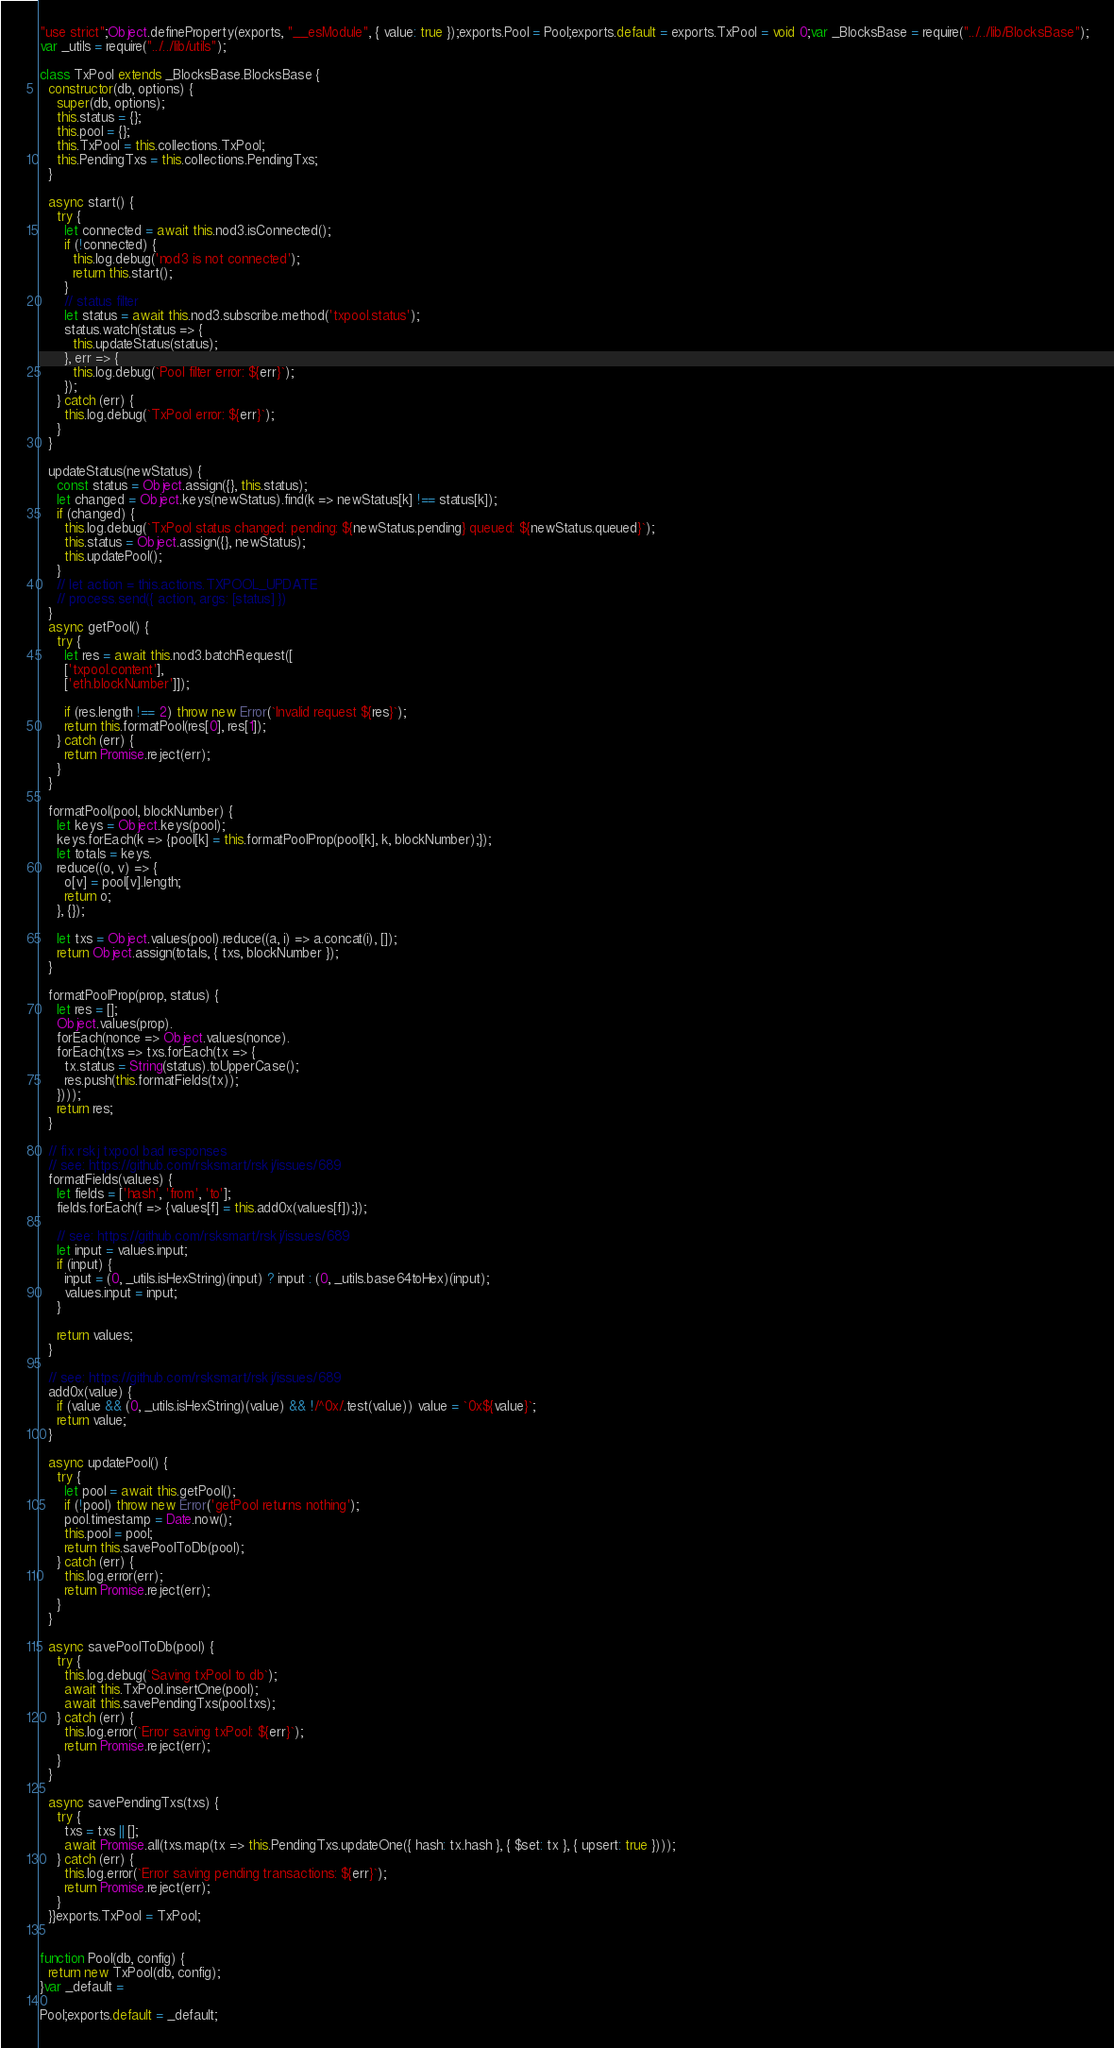Convert code to text. <code><loc_0><loc_0><loc_500><loc_500><_JavaScript_>"use strict";Object.defineProperty(exports, "__esModule", { value: true });exports.Pool = Pool;exports.default = exports.TxPool = void 0;var _BlocksBase = require("../../lib/BlocksBase");
var _utils = require("../../lib/utils");

class TxPool extends _BlocksBase.BlocksBase {
  constructor(db, options) {
    super(db, options);
    this.status = {};
    this.pool = {};
    this.TxPool = this.collections.TxPool;
    this.PendingTxs = this.collections.PendingTxs;
  }

  async start() {
    try {
      let connected = await this.nod3.isConnected();
      if (!connected) {
        this.log.debug('nod3 is not connected');
        return this.start();
      }
      // status filter
      let status = await this.nod3.subscribe.method('txpool.status');
      status.watch(status => {
        this.updateStatus(status);
      }, err => {
        this.log.debug(`Pool filter error: ${err}`);
      });
    } catch (err) {
      this.log.debug(`TxPool error: ${err}`);
    }
  }

  updateStatus(newStatus) {
    const status = Object.assign({}, this.status);
    let changed = Object.keys(newStatus).find(k => newStatus[k] !== status[k]);
    if (changed) {
      this.log.debug(`TxPool status changed: pending: ${newStatus.pending} queued: ${newStatus.queued}`);
      this.status = Object.assign({}, newStatus);
      this.updatePool();
    }
    // let action = this.actions.TXPOOL_UPDATE
    // process.send({ action, args: [status] })
  }
  async getPool() {
    try {
      let res = await this.nod3.batchRequest([
      ['txpool.content'],
      ['eth.blockNumber']]);

      if (res.length !== 2) throw new Error(`Invalid request ${res}`);
      return this.formatPool(res[0], res[1]);
    } catch (err) {
      return Promise.reject(err);
    }
  }

  formatPool(pool, blockNumber) {
    let keys = Object.keys(pool);
    keys.forEach(k => {pool[k] = this.formatPoolProp(pool[k], k, blockNumber);});
    let totals = keys.
    reduce((o, v) => {
      o[v] = pool[v].length;
      return o;
    }, {});

    let txs = Object.values(pool).reduce((a, i) => a.concat(i), []);
    return Object.assign(totals, { txs, blockNumber });
  }

  formatPoolProp(prop, status) {
    let res = [];
    Object.values(prop).
    forEach(nonce => Object.values(nonce).
    forEach(txs => txs.forEach(tx => {
      tx.status = String(status).toUpperCase();
      res.push(this.formatFields(tx));
    })));
    return res;
  }

  // fix rskj txpool bad responses
  // see: https://github.com/rsksmart/rskj/issues/689
  formatFields(values) {
    let fields = ['hash', 'from', 'to'];
    fields.forEach(f => {values[f] = this.add0x(values[f]);});

    // see: https://github.com/rsksmart/rskj/issues/689
    let input = values.input;
    if (input) {
      input = (0, _utils.isHexString)(input) ? input : (0, _utils.base64toHex)(input);
      values.input = input;
    }

    return values;
  }

  // see: https://github.com/rsksmart/rskj/issues/689
  add0x(value) {
    if (value && (0, _utils.isHexString)(value) && !/^0x/.test(value)) value = `0x${value}`;
    return value;
  }

  async updatePool() {
    try {
      let pool = await this.getPool();
      if (!pool) throw new Error('getPool returns nothing');
      pool.timestamp = Date.now();
      this.pool = pool;
      return this.savePoolToDb(pool);
    } catch (err) {
      this.log.error(err);
      return Promise.reject(err);
    }
  }

  async savePoolToDb(pool) {
    try {
      this.log.debug(`Saving txPool to db`);
      await this.TxPool.insertOne(pool);
      await this.savePendingTxs(pool.txs);
    } catch (err) {
      this.log.error(`Error saving txPool: ${err}`);
      return Promise.reject(err);
    }
  }

  async savePendingTxs(txs) {
    try {
      txs = txs || [];
      await Promise.all(txs.map(tx => this.PendingTxs.updateOne({ hash: tx.hash }, { $set: tx }, { upsert: true })));
    } catch (err) {
      this.log.error(`Error saving pending transactions: ${err}`);
      return Promise.reject(err);
    }
  }}exports.TxPool = TxPool;


function Pool(db, config) {
  return new TxPool(db, config);
}var _default =

Pool;exports.default = _default;</code> 